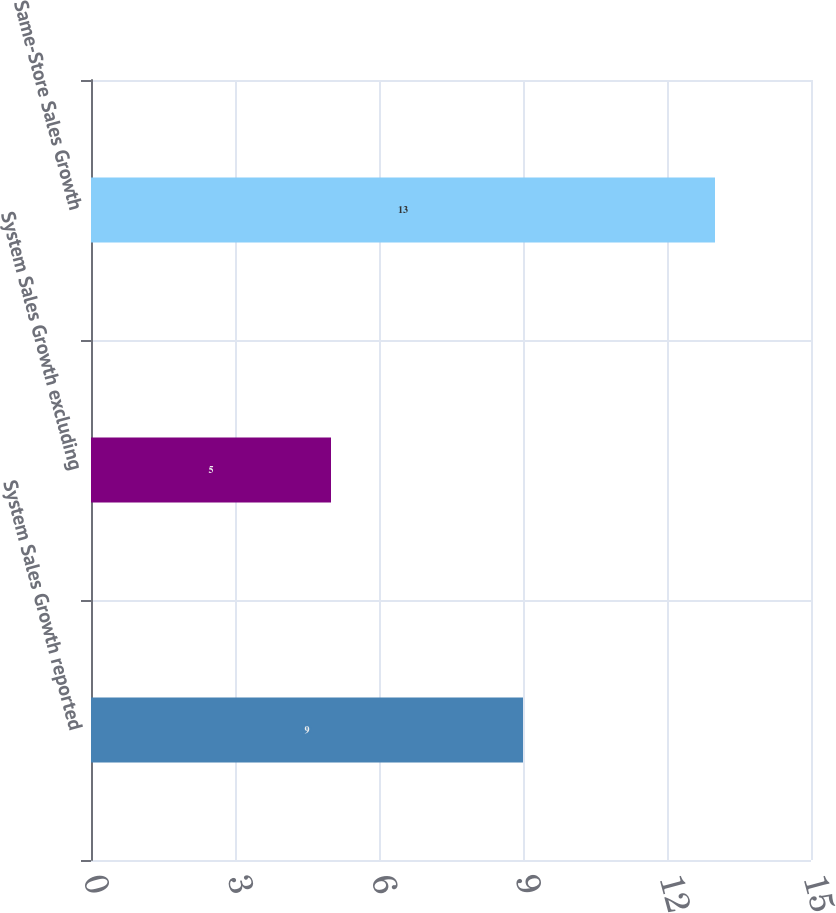Convert chart to OTSL. <chart><loc_0><loc_0><loc_500><loc_500><bar_chart><fcel>System Sales Growth reported<fcel>System Sales Growth excluding<fcel>Same-Store Sales Growth<nl><fcel>9<fcel>5<fcel>13<nl></chart> 